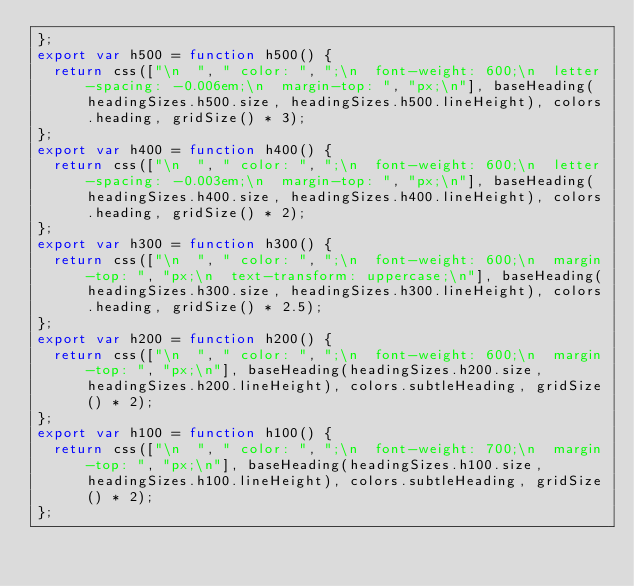Convert code to text. <code><loc_0><loc_0><loc_500><loc_500><_JavaScript_>};
export var h500 = function h500() {
  return css(["\n  ", " color: ", ";\n  font-weight: 600;\n  letter-spacing: -0.006em;\n  margin-top: ", "px;\n"], baseHeading(headingSizes.h500.size, headingSizes.h500.lineHeight), colors.heading, gridSize() * 3);
};
export var h400 = function h400() {
  return css(["\n  ", " color: ", ";\n  font-weight: 600;\n  letter-spacing: -0.003em;\n  margin-top: ", "px;\n"], baseHeading(headingSizes.h400.size, headingSizes.h400.lineHeight), colors.heading, gridSize() * 2);
};
export var h300 = function h300() {
  return css(["\n  ", " color: ", ";\n  font-weight: 600;\n  margin-top: ", "px;\n  text-transform: uppercase;\n"], baseHeading(headingSizes.h300.size, headingSizes.h300.lineHeight), colors.heading, gridSize() * 2.5);
};
export var h200 = function h200() {
  return css(["\n  ", " color: ", ";\n  font-weight: 600;\n  margin-top: ", "px;\n"], baseHeading(headingSizes.h200.size, headingSizes.h200.lineHeight), colors.subtleHeading, gridSize() * 2);
};
export var h100 = function h100() {
  return css(["\n  ", " color: ", ";\n  font-weight: 700;\n  margin-top: ", "px;\n"], baseHeading(headingSizes.h100.size, headingSizes.h100.lineHeight), colors.subtleHeading, gridSize() * 2);
};</code> 